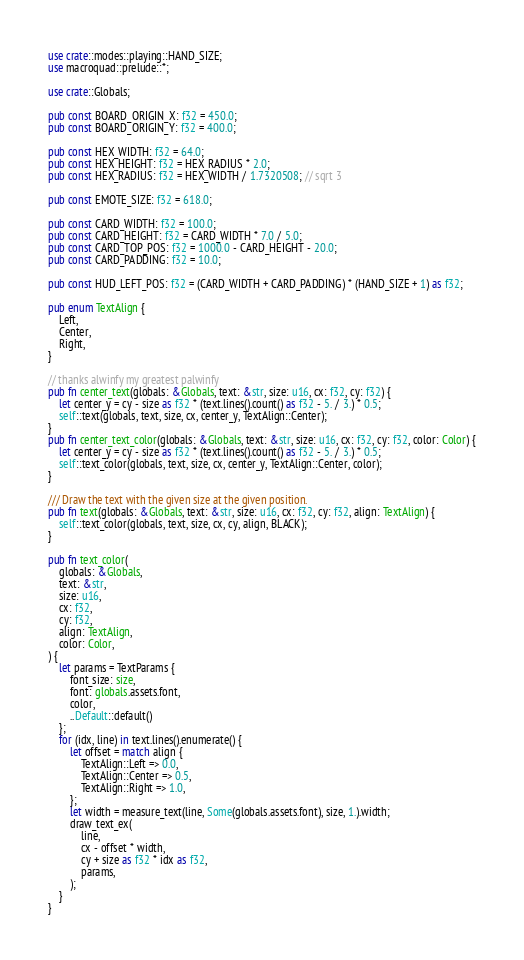Convert code to text. <code><loc_0><loc_0><loc_500><loc_500><_Rust_>use crate::modes::playing::HAND_SIZE;
use macroquad::prelude::*;

use crate::Globals;

pub const BOARD_ORIGIN_X: f32 = 450.0;
pub const BOARD_ORIGIN_Y: f32 = 400.0;

pub const HEX_WIDTH: f32 = 64.0;
pub const HEX_HEIGHT: f32 = HEX_RADIUS * 2.0;
pub const HEX_RADIUS: f32 = HEX_WIDTH / 1.7320508; // sqrt 3

pub const EMOTE_SIZE: f32 = 618.0;

pub const CARD_WIDTH: f32 = 100.0;
pub const CARD_HEIGHT: f32 = CARD_WIDTH * 7.0 / 5.0;
pub const CARD_TOP_POS: f32 = 1000.0 - CARD_HEIGHT - 20.0;
pub const CARD_PADDING: f32 = 10.0;

pub const HUD_LEFT_POS: f32 = (CARD_WIDTH + CARD_PADDING) * (HAND_SIZE + 1) as f32;

pub enum TextAlign {
    Left,
    Center,
    Right,
}

// thanks alwinfy my greatest palwinfy
pub fn center_text(globals: &Globals, text: &str, size: u16, cx: f32, cy: f32) {
    let center_y = cy - size as f32 * (text.lines().count() as f32 - 5. / 3.) * 0.5;
    self::text(globals, text, size, cx, center_y, TextAlign::Center);
}
pub fn center_text_color(globals: &Globals, text: &str, size: u16, cx: f32, cy: f32, color: Color) {
    let center_y = cy - size as f32 * (text.lines().count() as f32 - 5. / 3.) * 0.5;
    self::text_color(globals, text, size, cx, center_y, TextAlign::Center, color);
}

/// Draw the text with the given size at the given position.
pub fn text(globals: &Globals, text: &str, size: u16, cx: f32, cy: f32, align: TextAlign) {
    self::text_color(globals, text, size, cx, cy, align, BLACK);
}

pub fn text_color(
    globals: &Globals,
    text: &str,
    size: u16,
    cx: f32,
    cy: f32,
    align: TextAlign,
    color: Color,
) {
    let params = TextParams {
        font_size: size,
        font: globals.assets.font,
        color,
        ..Default::default()
    };
    for (idx, line) in text.lines().enumerate() {
        let offset = match align {
            TextAlign::Left => 0.0,
            TextAlign::Center => 0.5,
            TextAlign::Right => 1.0,
        };
        let width = measure_text(line, Some(globals.assets.font), size, 1.).width;
        draw_text_ex(
            line,
            cx - offset * width,
            cy + size as f32 * idx as f32,
            params,
        );
    }
}
</code> 